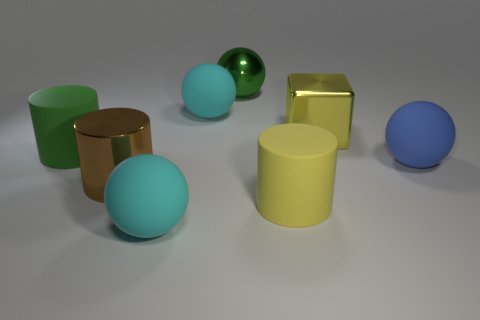How many cyan spheres must be subtracted to get 1 cyan spheres? 1 Subtract all blue blocks. Subtract all blue spheres. How many blocks are left? 1 Add 1 tiny green shiny blocks. How many objects exist? 9 Subtract all cubes. How many objects are left? 7 Add 5 blue things. How many blue things are left? 6 Add 8 large brown cylinders. How many large brown cylinders exist? 9 Subtract 0 brown balls. How many objects are left? 8 Subtract all large metal balls. Subtract all small metal cylinders. How many objects are left? 7 